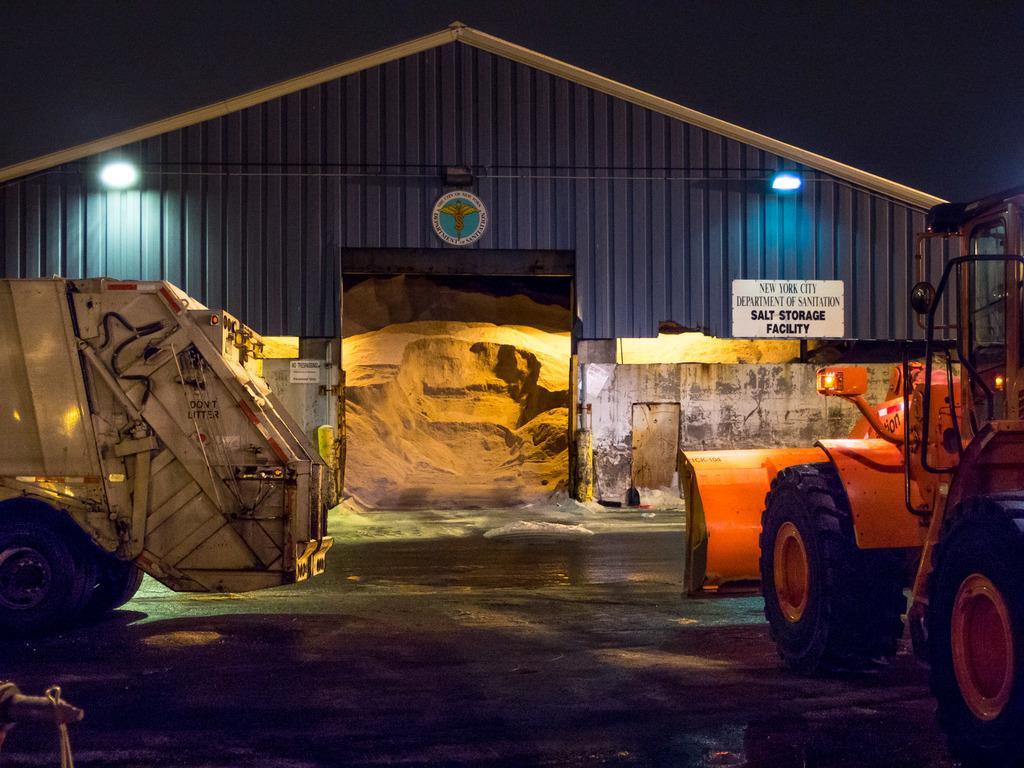Please provide a concise description of this image. In this picture in the center there are vehicles. In the background there is a cottage and inside the cottage there is send and on the wall of the cottage there is some text written on it and there are two lights. 